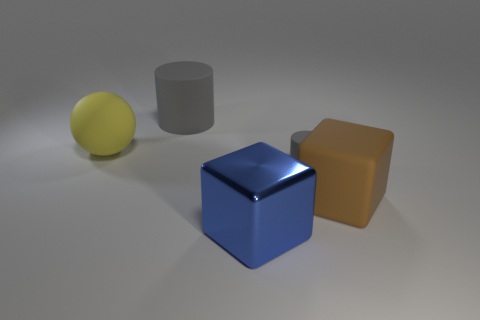There is a gray thing that is right of the big blue block; does it have the same shape as the thing that is behind the large rubber sphere?
Make the answer very short. Yes. What number of other objects are there of the same color as the tiny cylinder?
Your response must be concise. 1. Is the size of the cylinder in front of the yellow object the same as the big yellow matte object?
Your answer should be compact. No. Is the material of the gray object left of the small rubber thing the same as the object that is in front of the brown cube?
Your answer should be very brief. No. Are there any purple shiny objects that have the same size as the matte block?
Your answer should be very brief. No. What is the shape of the big matte thing that is in front of the gray rubber object that is in front of the matte cylinder to the left of the tiny matte cylinder?
Provide a succinct answer. Cube. Are there more large rubber things to the left of the big brown rubber thing than small rubber things?
Provide a succinct answer. Yes. Are there any big blue things of the same shape as the yellow matte object?
Offer a terse response. No. Do the large ball and the gray cylinder left of the blue shiny cube have the same material?
Keep it short and to the point. Yes. What color is the tiny cylinder?
Offer a terse response. Gray. 